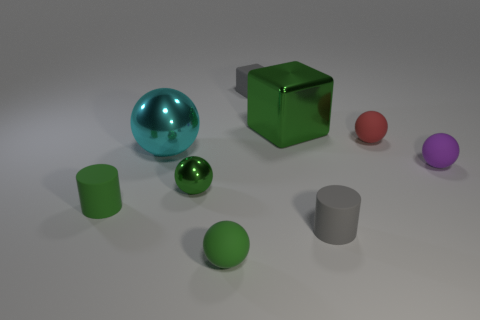There is a tiny purple thing that is the same shape as the cyan metal thing; what material is it?
Offer a very short reply. Rubber. What shape is the gray thing that is the same size as the gray matte cylinder?
Ensure brevity in your answer.  Cube. How many tiny matte cylinders are the same color as the small block?
Your response must be concise. 1. Are there fewer big cyan spheres in front of the big cyan metal thing than small cylinders that are on the left side of the tiny green rubber sphere?
Provide a short and direct response. Yes. Are there any small rubber cylinders to the right of the green shiny ball?
Your answer should be very brief. Yes. There is a shiny thing that is behind the matte sphere that is behind the tiny purple matte ball; is there a small ball that is behind it?
Offer a terse response. No. There is a tiny green object in front of the green cylinder; is its shape the same as the small metallic object?
Make the answer very short. Yes. The small sphere that is made of the same material as the large green thing is what color?
Your answer should be compact. Green. What number of tiny yellow spheres are made of the same material as the gray cylinder?
Your response must be concise. 0. The matte cylinder that is in front of the cylinder on the left side of the green matte thing in front of the tiny gray rubber cylinder is what color?
Your answer should be compact. Gray. 